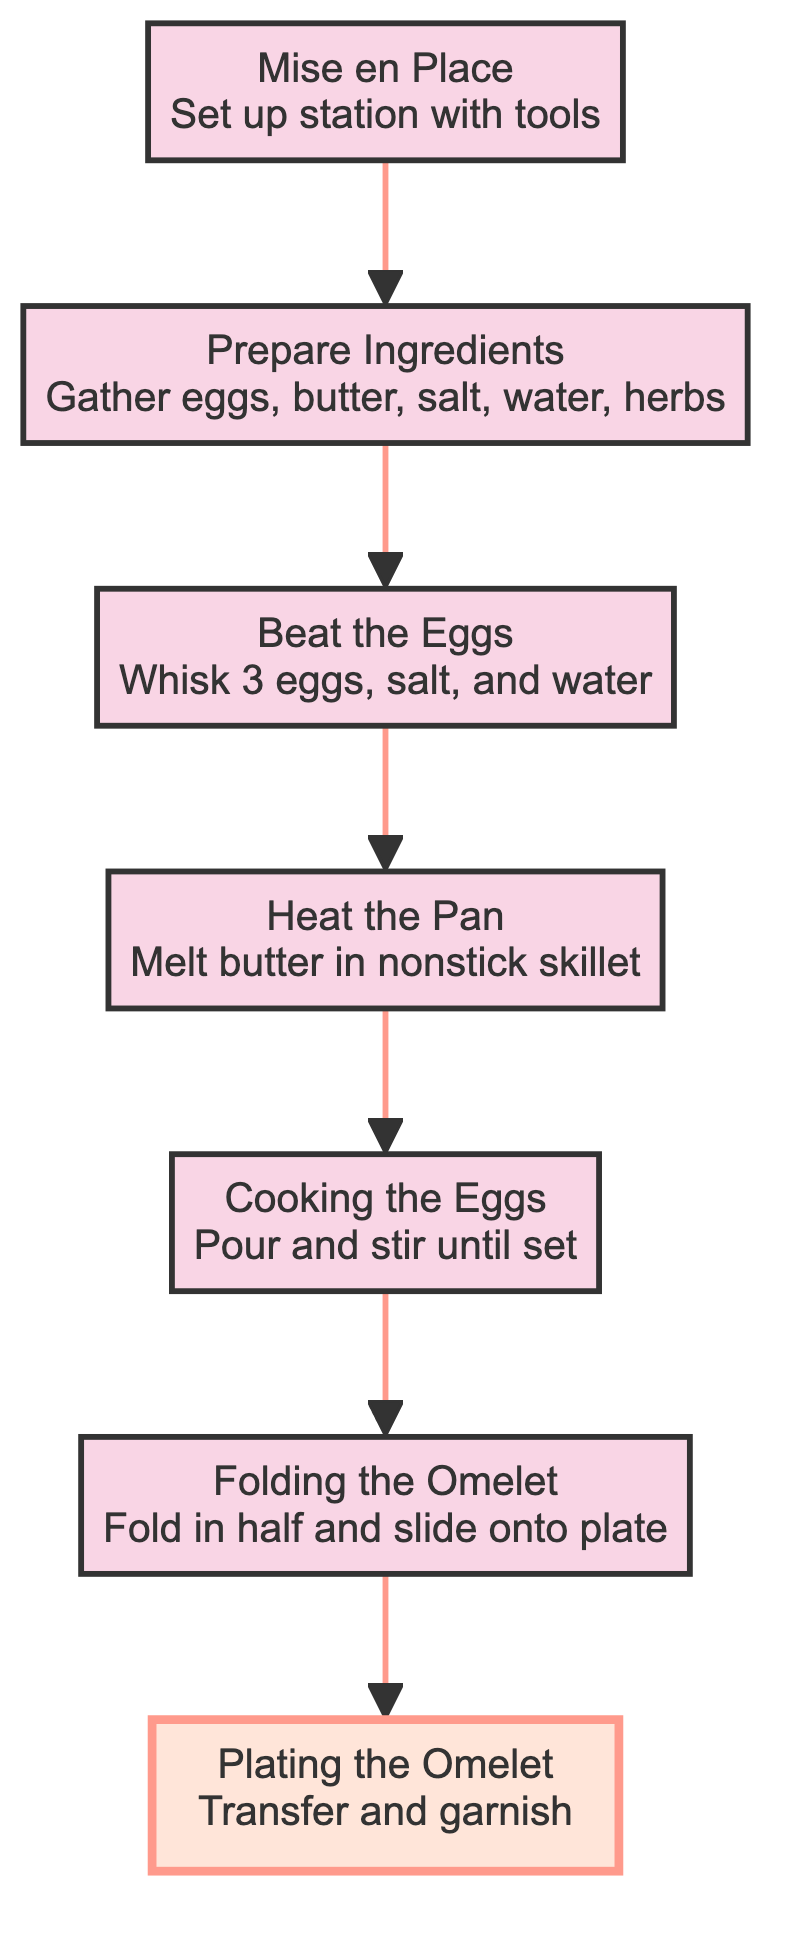What is the top node of the diagram? The top node of the diagram is "Plating the Omelet." This is identified as the first node in the flow chart when traced from the bottom to the top.
Answer: Plating the Omelet How many nodes are in the flow chart? The flow chart contains 7 nodes, which are each distinct steps in the process. Each node represents an individual instruction from the beginning to the end of the process.
Answer: 7 What step comes before "Cooking the Eggs"? The step that comes before "Cooking the Eggs" is "Heat the Pan." This sequence can be determined by identifying the direct flow of instructions leading to "Cooking the Eggs."
Answer: Heat the Pan Which ingredient is optional in the preparation? Fresh herbs like chives or parsley are the optional ingredients in the preparation of the omelet, marked in the node “Prepare Ingredients.”
Answer: Fresh herbs What is the action taken in the node "Folding the Omelet"? The action taken in "Folding the Omelet" is to gently fold the omelet in half using a spatula and slide it onto a plate. This is the instruction outlined in that particular node.
Answer: Gently fold What is the final action in the flow chart? The final action in the flow chart is "Transfer and garnish," which is found in the last node "Plating the Omelet." This indicates the last step in the process of preparing the omelet.
Answer: Transfer and garnish How does "Beat the Eggs" relate to "Prepare Ingredients"? "Beat the Eggs" follows "Prepare Ingredients," meaning it occurs after gathering all necessary items. This shows the sequential nature of the preparation, where preparation must precede beating the eggs.
Answer: It follows What tool is necessary for whisking the eggs? The necessary tool for whisking the eggs is a whisk, as specified in the node "Mise en Place," which sets up all required tools for the recipe.
Answer: Whisk 